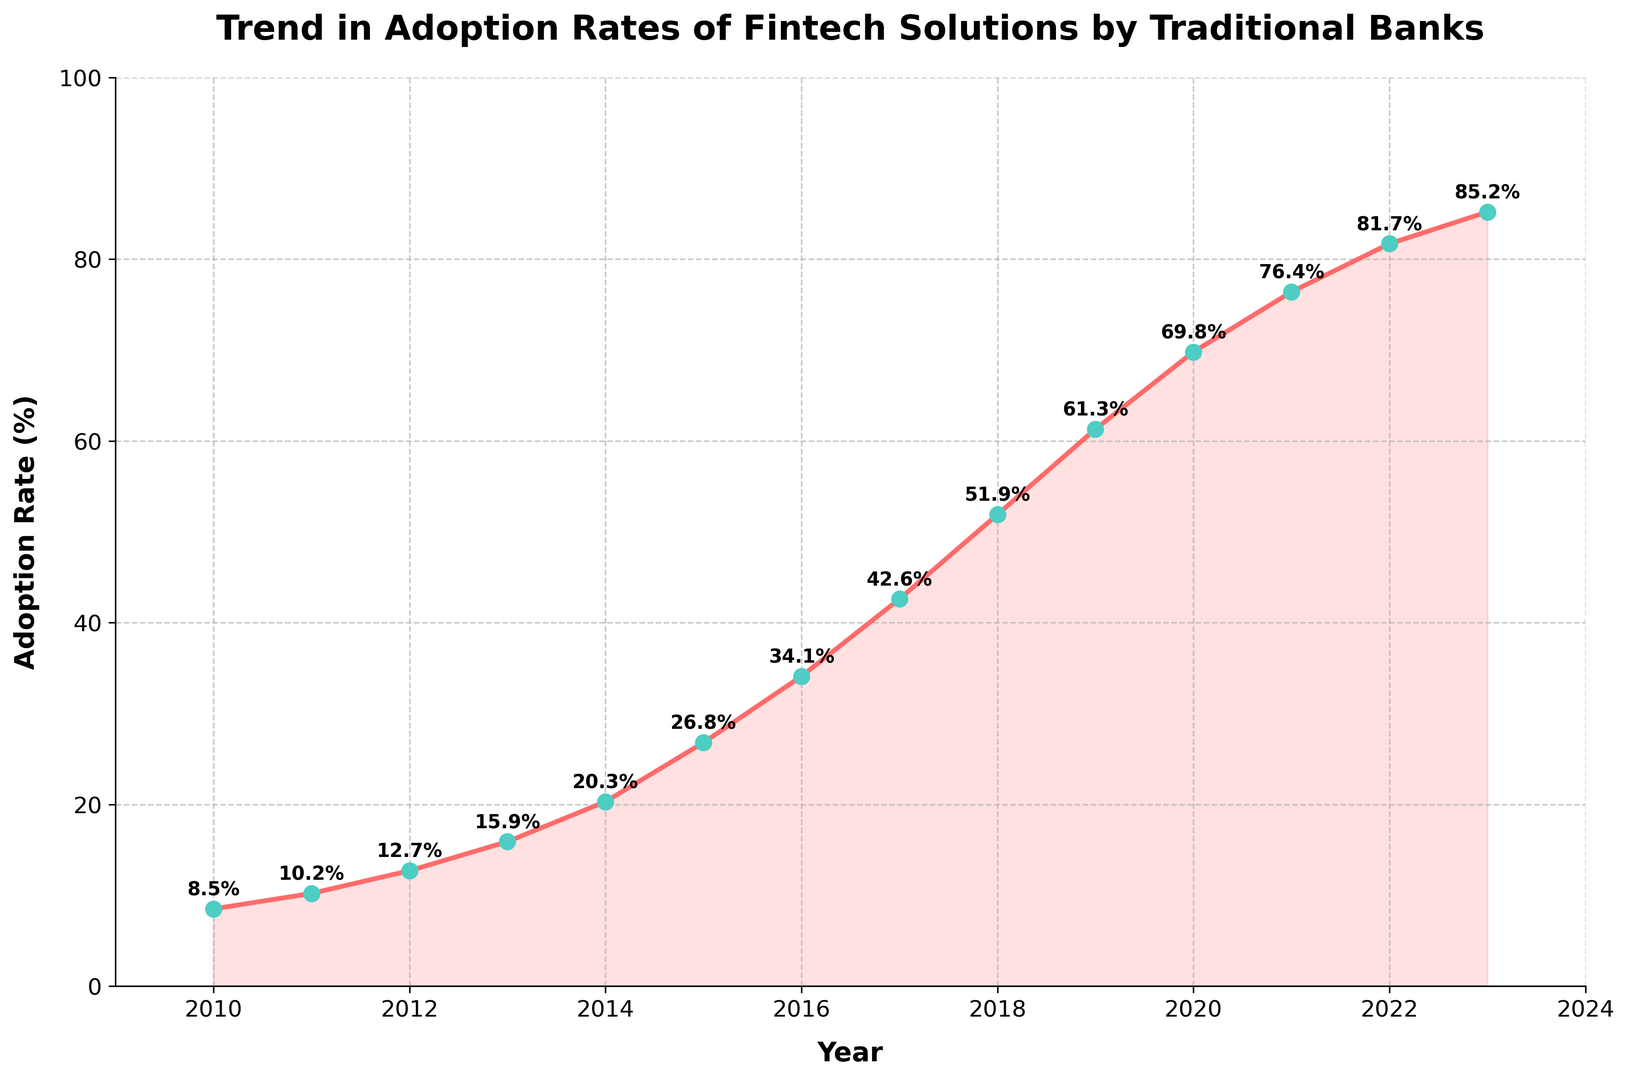What was the adoption rate of fintech solutions by traditional banks in 2015? Find the year 2015 on the x-axis and look at the corresponding point on the line to see the adoption rate. The rate is annotated next to the point.
Answer: 26.8% Between which two consecutive years did the adoption rate increase the most? Check the difference in adoption rates between each consecutive year. The largest difference is between 2018 and 2019 (61.3% - 51.9% = 9.4%).
Answer: 2018 and 2019 What is the average adoption rate from 2010 to 2015? Add the adoption rates from 2010 to 2015 (8.5% + 10.2% + 12.7% + 15.9% + 20.3% + 26.8%) and divide by the number of years (6). The sum is 94.4%, so the average is 94.4% / 6 = 15.73%.
Answer: 15.73% By how much did the adoption rate increase from 2010 to 2023? Subtract the adoption rate in 2010 from the rate in 2023 (85.2% - 8.5% = 76.7%).
Answer: 76.7% In which year did the adoption rate first surpass 50%? Look at the x-axis and find the first year when the adoption rate annotates a value above 50%. It occurred in 2018 at 51.9%.
Answer: 2018 Which year saw the smallest increase in adoption rate compared to the previous year? Calculate the increase for each year and find the smallest. The smallest increase is from 2021 to 2022 (81.7% - 76.4% = 5.3%).
Answer: 2022 How many years did it take for the adoption rate to grow from less than 20% to more than 60%? Find the year when the adoption rate surpassed 20% (2014) and the year when it surpassed 60% (2019). The difference is 2019 - 2014 = 5 years.
Answer: 5 years What is the total increase in adoption rate from 2010 to 2015 and from 2015 to 2020 combined? Calculate the total increase from 2010 to 2015 (26.8% - 8.5% = 18.3%) and from 2015 to 2020 (69.8% - 26.8% = 43%). The combined increase is 18.3% + 43% = 61.3%.
Answer: 61.3% How does the adoption rate in 2020 compare with that in 2010? Compare the values in 2020 (69.8%) and 2010 (8.5%). 69.8% is significantly higher than 8.5%.
Answer: Significantly higher 